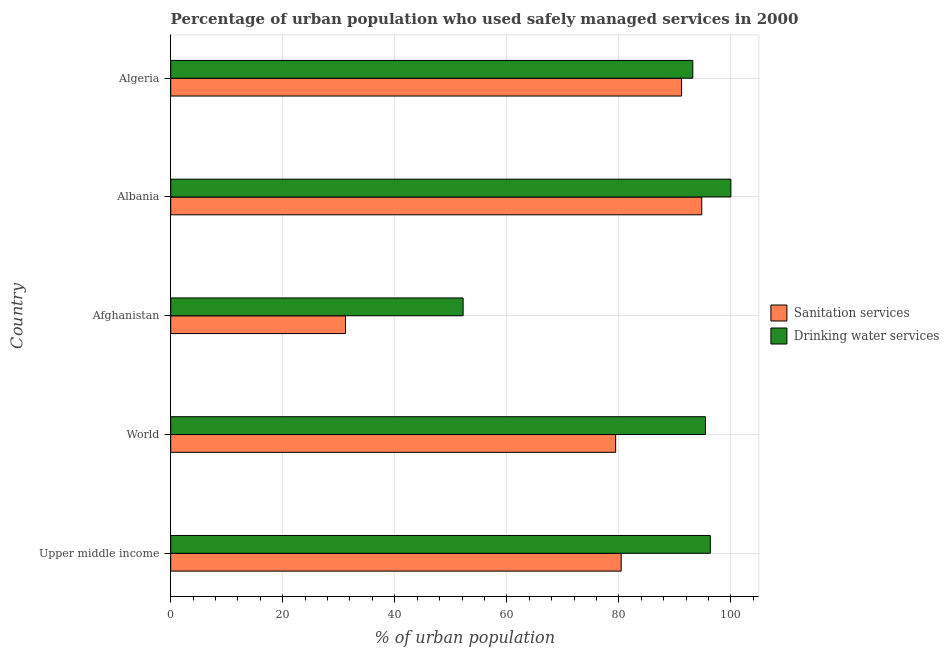How many groups of bars are there?
Offer a terse response. 5. Are the number of bars per tick equal to the number of legend labels?
Make the answer very short. Yes. Are the number of bars on each tick of the Y-axis equal?
Give a very brief answer. Yes. How many bars are there on the 1st tick from the bottom?
Your answer should be very brief. 2. What is the label of the 4th group of bars from the top?
Keep it short and to the point. World. In how many cases, is the number of bars for a given country not equal to the number of legend labels?
Make the answer very short. 0. What is the percentage of urban population who used drinking water services in Afghanistan?
Make the answer very short. 52.2. Across all countries, what is the maximum percentage of urban population who used sanitation services?
Your answer should be very brief. 94.8. Across all countries, what is the minimum percentage of urban population who used sanitation services?
Your response must be concise. 31.2. In which country was the percentage of urban population who used sanitation services maximum?
Provide a succinct answer. Albania. In which country was the percentage of urban population who used sanitation services minimum?
Your answer should be compact. Afghanistan. What is the total percentage of urban population who used drinking water services in the graph?
Your answer should be compact. 437.18. What is the difference between the percentage of urban population who used drinking water services in Upper middle income and that in World?
Provide a short and direct response. 0.86. What is the difference between the percentage of urban population who used sanitation services in World and the percentage of urban population who used drinking water services in Afghanistan?
Keep it short and to the point. 27.23. What is the average percentage of urban population who used sanitation services per country?
Give a very brief answer. 75.41. What is the difference between the percentage of urban population who used sanitation services and percentage of urban population who used drinking water services in Upper middle income?
Give a very brief answer. -15.9. What is the ratio of the percentage of urban population who used drinking water services in Algeria to that in World?
Offer a terse response. 0.98. Is the percentage of urban population who used sanitation services in Albania less than that in World?
Offer a terse response. No. What is the difference between the highest and the second highest percentage of urban population who used drinking water services?
Provide a succinct answer. 3.68. What is the difference between the highest and the lowest percentage of urban population who used drinking water services?
Your answer should be very brief. 47.8. In how many countries, is the percentage of urban population who used drinking water services greater than the average percentage of urban population who used drinking water services taken over all countries?
Your response must be concise. 4. What does the 1st bar from the top in World represents?
Provide a succinct answer. Drinking water services. What does the 1st bar from the bottom in Algeria represents?
Keep it short and to the point. Sanitation services. How many countries are there in the graph?
Provide a short and direct response. 5. Are the values on the major ticks of X-axis written in scientific E-notation?
Provide a short and direct response. No. Does the graph contain grids?
Give a very brief answer. Yes. What is the title of the graph?
Offer a very short reply. Percentage of urban population who used safely managed services in 2000. What is the label or title of the X-axis?
Offer a terse response. % of urban population. What is the label or title of the Y-axis?
Keep it short and to the point. Country. What is the % of urban population of Sanitation services in Upper middle income?
Your answer should be compact. 80.42. What is the % of urban population of Drinking water services in Upper middle income?
Your response must be concise. 96.32. What is the % of urban population of Sanitation services in World?
Your response must be concise. 79.43. What is the % of urban population of Drinking water services in World?
Make the answer very short. 95.46. What is the % of urban population in Sanitation services in Afghanistan?
Offer a very short reply. 31.2. What is the % of urban population of Drinking water services in Afghanistan?
Keep it short and to the point. 52.2. What is the % of urban population of Sanitation services in Albania?
Make the answer very short. 94.8. What is the % of urban population of Drinking water services in Albania?
Your answer should be compact. 100. What is the % of urban population in Sanitation services in Algeria?
Give a very brief answer. 91.2. What is the % of urban population of Drinking water services in Algeria?
Your answer should be compact. 93.2. Across all countries, what is the maximum % of urban population of Sanitation services?
Ensure brevity in your answer.  94.8. Across all countries, what is the maximum % of urban population of Drinking water services?
Offer a terse response. 100. Across all countries, what is the minimum % of urban population of Sanitation services?
Your answer should be very brief. 31.2. Across all countries, what is the minimum % of urban population of Drinking water services?
Offer a very short reply. 52.2. What is the total % of urban population in Sanitation services in the graph?
Keep it short and to the point. 377.05. What is the total % of urban population in Drinking water services in the graph?
Provide a succinct answer. 437.18. What is the difference between the % of urban population in Sanitation services in Upper middle income and that in World?
Your answer should be very brief. 0.99. What is the difference between the % of urban population in Drinking water services in Upper middle income and that in World?
Your answer should be very brief. 0.86. What is the difference between the % of urban population of Sanitation services in Upper middle income and that in Afghanistan?
Your answer should be very brief. 49.22. What is the difference between the % of urban population of Drinking water services in Upper middle income and that in Afghanistan?
Offer a terse response. 44.12. What is the difference between the % of urban population of Sanitation services in Upper middle income and that in Albania?
Your response must be concise. -14.38. What is the difference between the % of urban population of Drinking water services in Upper middle income and that in Albania?
Give a very brief answer. -3.68. What is the difference between the % of urban population of Sanitation services in Upper middle income and that in Algeria?
Provide a short and direct response. -10.78. What is the difference between the % of urban population of Drinking water services in Upper middle income and that in Algeria?
Your response must be concise. 3.12. What is the difference between the % of urban population in Sanitation services in World and that in Afghanistan?
Your answer should be very brief. 48.23. What is the difference between the % of urban population of Drinking water services in World and that in Afghanistan?
Your answer should be compact. 43.26. What is the difference between the % of urban population of Sanitation services in World and that in Albania?
Ensure brevity in your answer.  -15.37. What is the difference between the % of urban population of Drinking water services in World and that in Albania?
Your response must be concise. -4.54. What is the difference between the % of urban population of Sanitation services in World and that in Algeria?
Give a very brief answer. -11.77. What is the difference between the % of urban population of Drinking water services in World and that in Algeria?
Keep it short and to the point. 2.26. What is the difference between the % of urban population in Sanitation services in Afghanistan and that in Albania?
Provide a short and direct response. -63.6. What is the difference between the % of urban population in Drinking water services in Afghanistan and that in Albania?
Provide a succinct answer. -47.8. What is the difference between the % of urban population of Sanitation services in Afghanistan and that in Algeria?
Make the answer very short. -60. What is the difference between the % of urban population of Drinking water services in Afghanistan and that in Algeria?
Your answer should be very brief. -41. What is the difference between the % of urban population in Sanitation services in Upper middle income and the % of urban population in Drinking water services in World?
Your response must be concise. -15.04. What is the difference between the % of urban population in Sanitation services in Upper middle income and the % of urban population in Drinking water services in Afghanistan?
Give a very brief answer. 28.22. What is the difference between the % of urban population in Sanitation services in Upper middle income and the % of urban population in Drinking water services in Albania?
Ensure brevity in your answer.  -19.58. What is the difference between the % of urban population of Sanitation services in Upper middle income and the % of urban population of Drinking water services in Algeria?
Give a very brief answer. -12.78. What is the difference between the % of urban population in Sanitation services in World and the % of urban population in Drinking water services in Afghanistan?
Ensure brevity in your answer.  27.23. What is the difference between the % of urban population of Sanitation services in World and the % of urban population of Drinking water services in Albania?
Keep it short and to the point. -20.57. What is the difference between the % of urban population of Sanitation services in World and the % of urban population of Drinking water services in Algeria?
Offer a very short reply. -13.77. What is the difference between the % of urban population in Sanitation services in Afghanistan and the % of urban population in Drinking water services in Albania?
Provide a short and direct response. -68.8. What is the difference between the % of urban population in Sanitation services in Afghanistan and the % of urban population in Drinking water services in Algeria?
Keep it short and to the point. -62. What is the average % of urban population of Sanitation services per country?
Keep it short and to the point. 75.41. What is the average % of urban population in Drinking water services per country?
Keep it short and to the point. 87.44. What is the difference between the % of urban population in Sanitation services and % of urban population in Drinking water services in Upper middle income?
Give a very brief answer. -15.9. What is the difference between the % of urban population of Sanitation services and % of urban population of Drinking water services in World?
Provide a succinct answer. -16.03. What is the difference between the % of urban population of Sanitation services and % of urban population of Drinking water services in Algeria?
Your response must be concise. -2. What is the ratio of the % of urban population of Sanitation services in Upper middle income to that in World?
Your answer should be compact. 1.01. What is the ratio of the % of urban population of Sanitation services in Upper middle income to that in Afghanistan?
Make the answer very short. 2.58. What is the ratio of the % of urban population in Drinking water services in Upper middle income to that in Afghanistan?
Provide a succinct answer. 1.85. What is the ratio of the % of urban population of Sanitation services in Upper middle income to that in Albania?
Your answer should be compact. 0.85. What is the ratio of the % of urban population of Drinking water services in Upper middle income to that in Albania?
Ensure brevity in your answer.  0.96. What is the ratio of the % of urban population in Sanitation services in Upper middle income to that in Algeria?
Your answer should be compact. 0.88. What is the ratio of the % of urban population in Drinking water services in Upper middle income to that in Algeria?
Make the answer very short. 1.03. What is the ratio of the % of urban population in Sanitation services in World to that in Afghanistan?
Offer a terse response. 2.55. What is the ratio of the % of urban population of Drinking water services in World to that in Afghanistan?
Give a very brief answer. 1.83. What is the ratio of the % of urban population in Sanitation services in World to that in Albania?
Provide a succinct answer. 0.84. What is the ratio of the % of urban population of Drinking water services in World to that in Albania?
Provide a succinct answer. 0.95. What is the ratio of the % of urban population of Sanitation services in World to that in Algeria?
Provide a succinct answer. 0.87. What is the ratio of the % of urban population of Drinking water services in World to that in Algeria?
Your answer should be very brief. 1.02. What is the ratio of the % of urban population in Sanitation services in Afghanistan to that in Albania?
Provide a succinct answer. 0.33. What is the ratio of the % of urban population of Drinking water services in Afghanistan to that in Albania?
Offer a very short reply. 0.52. What is the ratio of the % of urban population of Sanitation services in Afghanistan to that in Algeria?
Your answer should be very brief. 0.34. What is the ratio of the % of urban population in Drinking water services in Afghanistan to that in Algeria?
Ensure brevity in your answer.  0.56. What is the ratio of the % of urban population in Sanitation services in Albania to that in Algeria?
Ensure brevity in your answer.  1.04. What is the ratio of the % of urban population in Drinking water services in Albania to that in Algeria?
Offer a very short reply. 1.07. What is the difference between the highest and the second highest % of urban population in Sanitation services?
Make the answer very short. 3.6. What is the difference between the highest and the second highest % of urban population of Drinking water services?
Offer a very short reply. 3.68. What is the difference between the highest and the lowest % of urban population of Sanitation services?
Your response must be concise. 63.6. What is the difference between the highest and the lowest % of urban population of Drinking water services?
Keep it short and to the point. 47.8. 